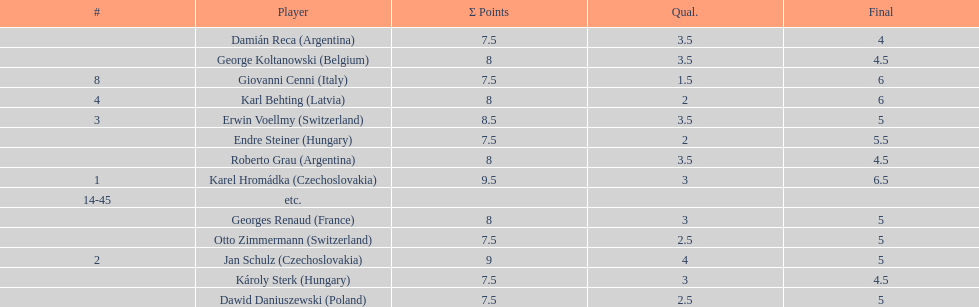How many countries had more than one player in the consolation cup? 4. 